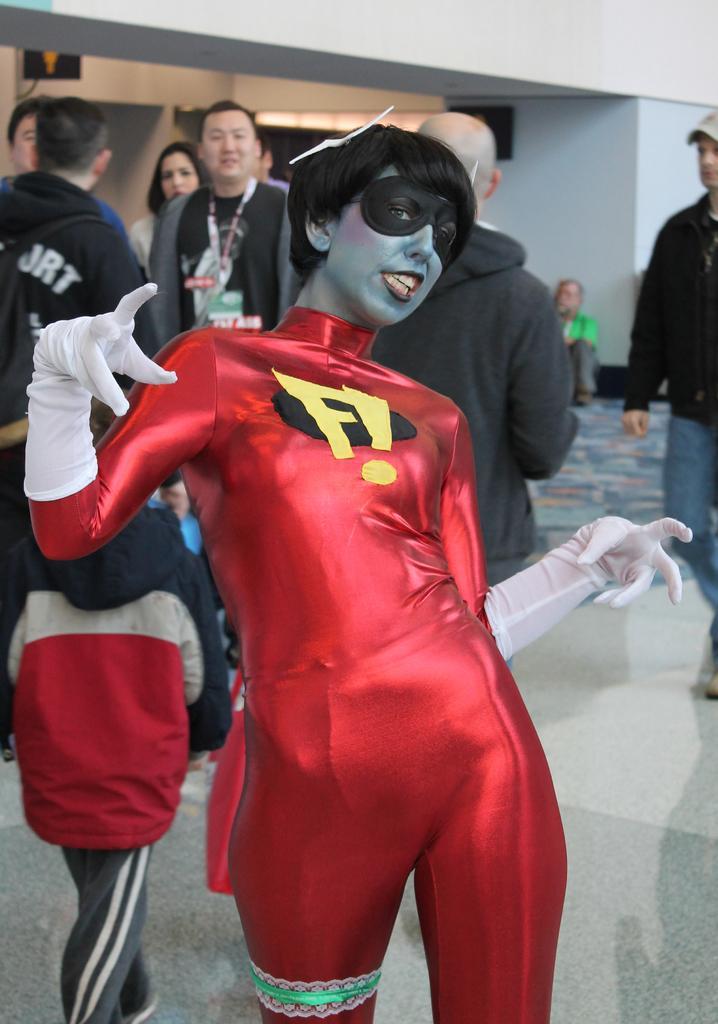Can you describe this image briefly? In this image we can see a woman wore a fancy dress and standing on the floor. In the background there are few persons and a person is sitting on the floor at the wall and there are boards on the wall and we can see the lights. 